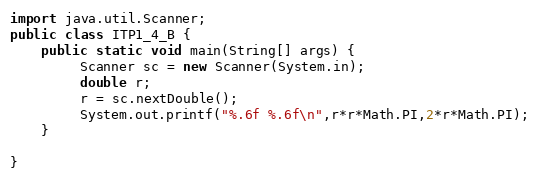<code> <loc_0><loc_0><loc_500><loc_500><_Java_>import java.util.Scanner;
public class ITP1_4_B {
	public static void main(String[] args) {
		 Scanner sc = new Scanner(System.in);
		 double r;
		 r = sc.nextDouble();         
		 System.out.printf("%.6f %.6f\n",r*r*Math.PI,2*r*Math.PI); 
	}

}</code> 